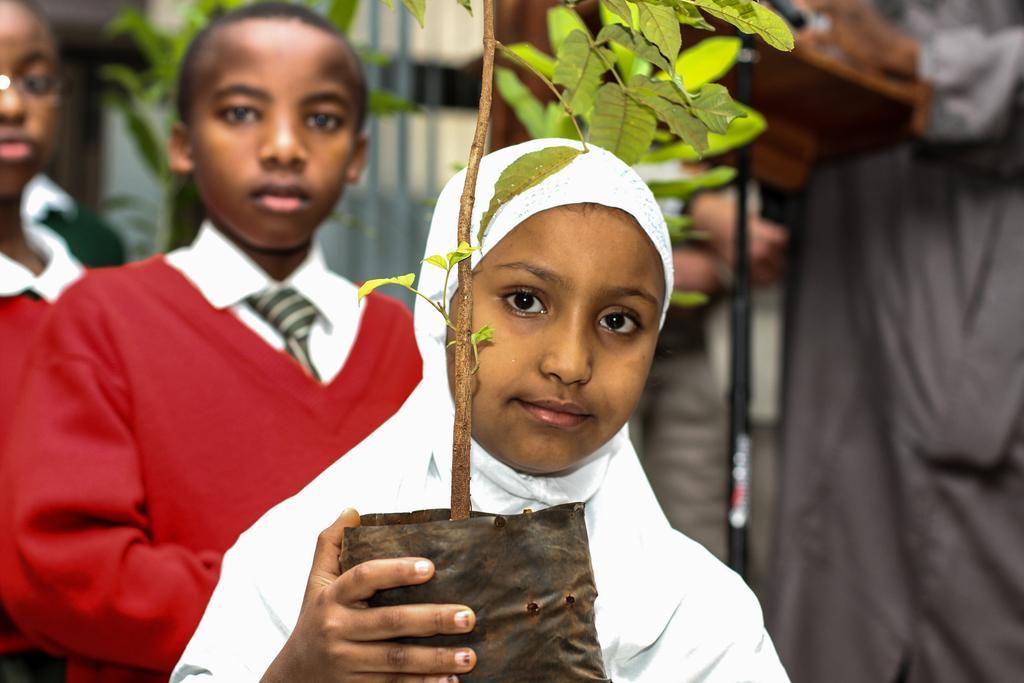How would you summarize this image in a sentence or two? In this picture we can see a kid is holding a plant. Behind the kid, there are two other kids, a person and some blurred objects. 